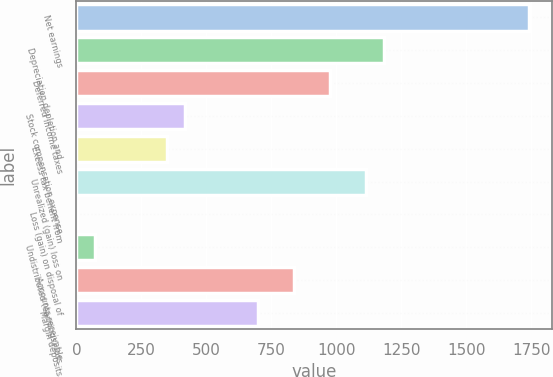<chart> <loc_0><loc_0><loc_500><loc_500><bar_chart><fcel>Net earnings<fcel>Depreciation depletion and<fcel>Deferred income taxes<fcel>Stock compensation expense<fcel>Excess tax benefit from<fcel>Unrealized (gain) loss on<fcel>Loss (gain) on disposal of<fcel>Undistributed (earnings) loss<fcel>Accounts receivable<fcel>Margin deposits<nl><fcel>1741.7<fcel>1184.58<fcel>975.66<fcel>418.54<fcel>348.9<fcel>1114.94<fcel>0.7<fcel>70.34<fcel>836.38<fcel>697.1<nl></chart> 